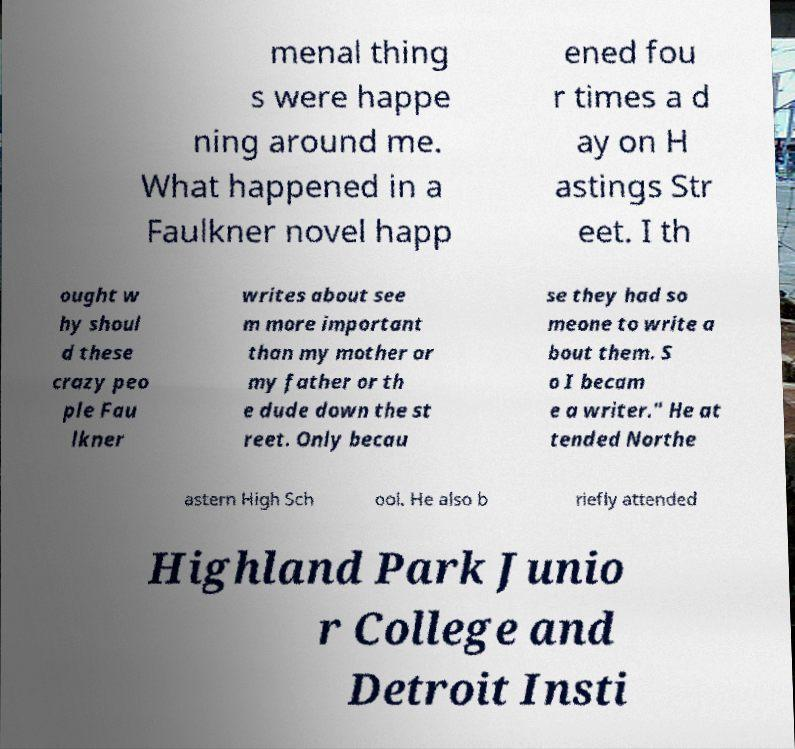Could you assist in decoding the text presented in this image and type it out clearly? menal thing s were happe ning around me. What happened in a Faulkner novel happ ened fou r times a d ay on H astings Str eet. I th ought w hy shoul d these crazy peo ple Fau lkner writes about see m more important than my mother or my father or th e dude down the st reet. Only becau se they had so meone to write a bout them. S o I becam e a writer." He at tended Northe astern High Sch ool. He also b riefly attended Highland Park Junio r College and Detroit Insti 